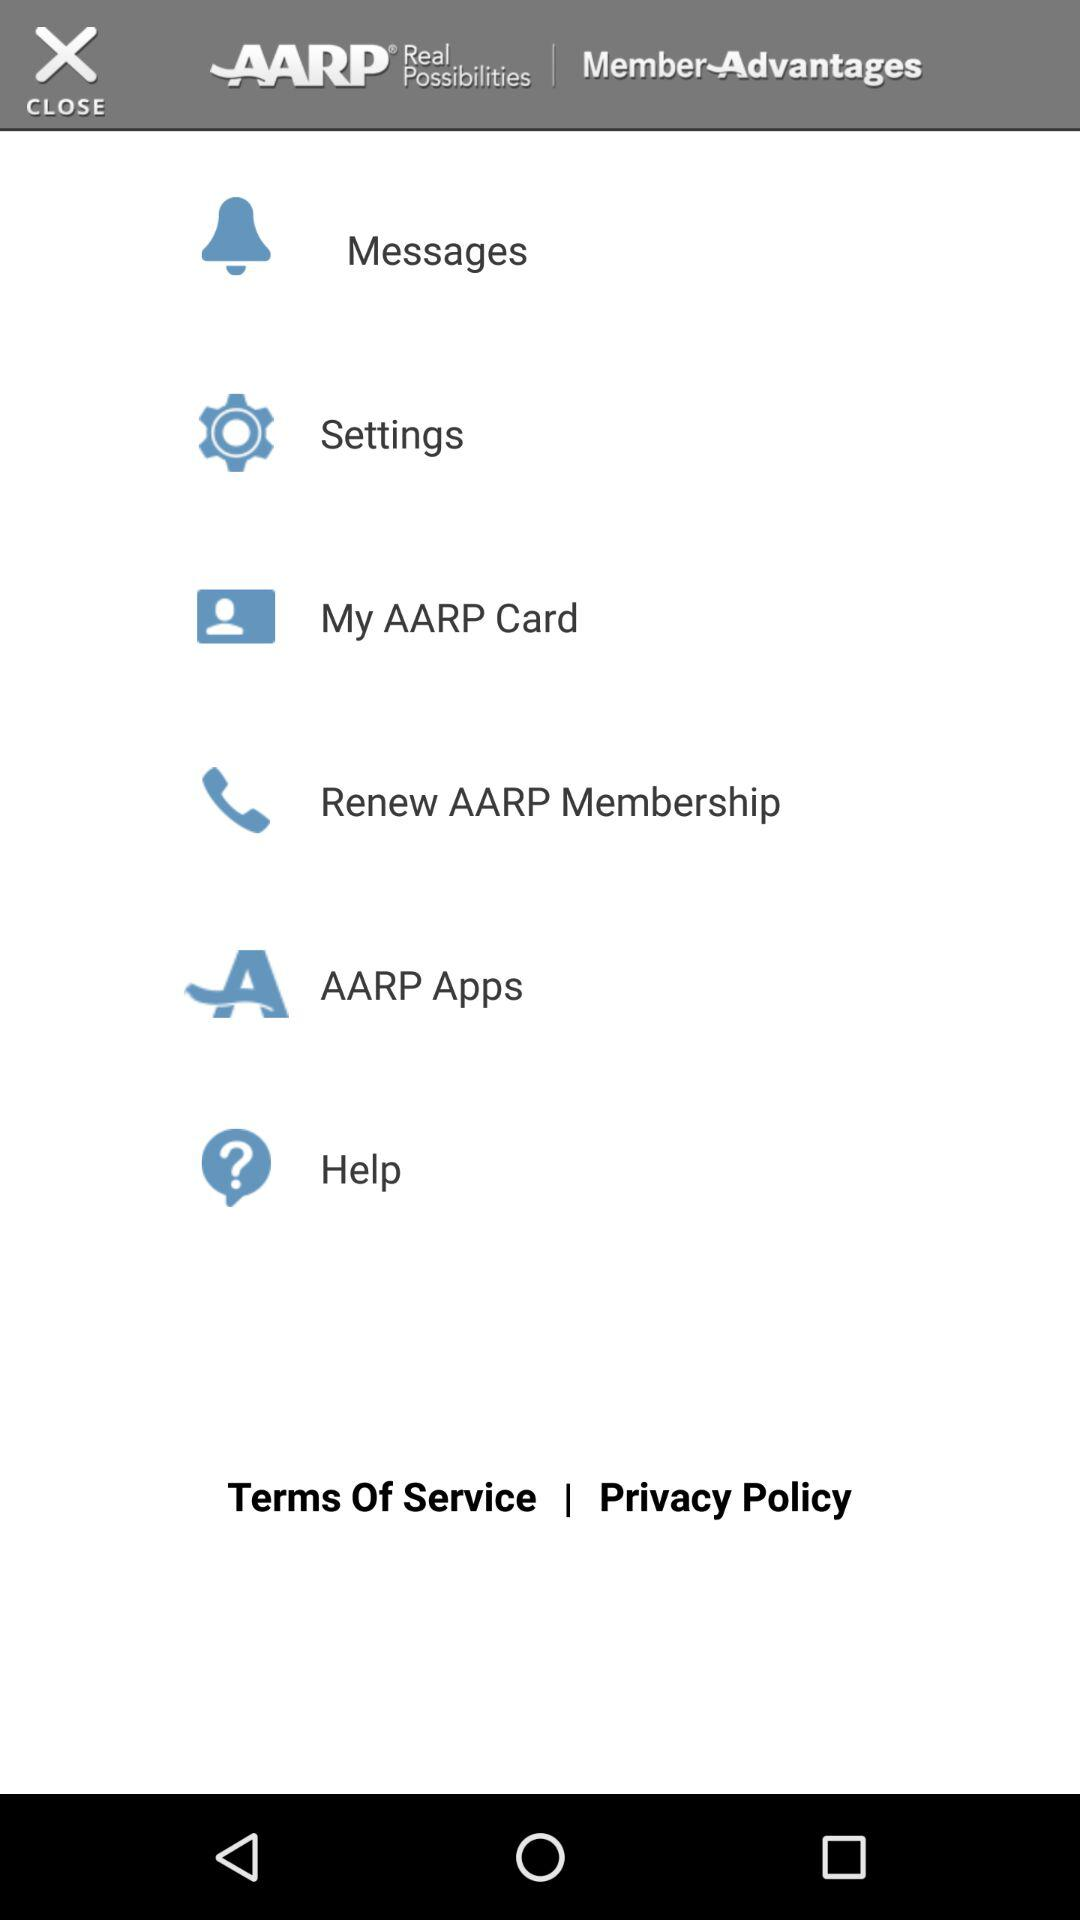What is the application name? The application name is "AARP". 